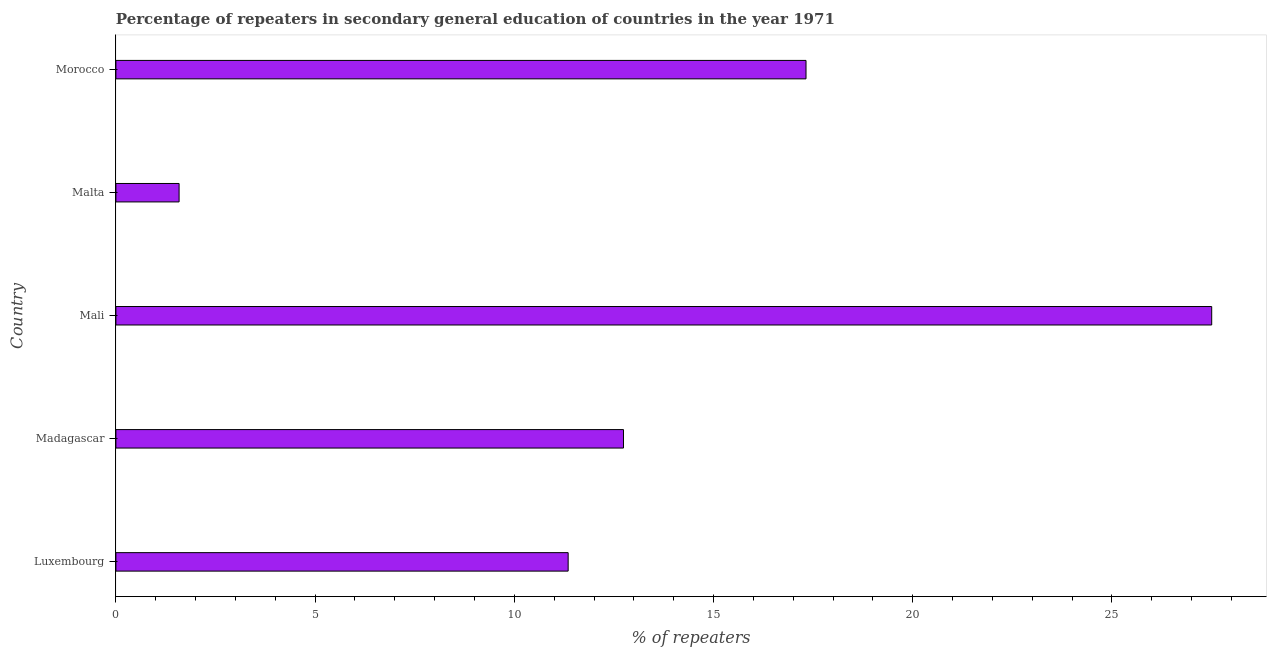Does the graph contain grids?
Your answer should be compact. No. What is the title of the graph?
Provide a short and direct response. Percentage of repeaters in secondary general education of countries in the year 1971. What is the label or title of the X-axis?
Your response must be concise. % of repeaters. What is the label or title of the Y-axis?
Your response must be concise. Country. What is the percentage of repeaters in Malta?
Provide a succinct answer. 1.59. Across all countries, what is the maximum percentage of repeaters?
Keep it short and to the point. 27.5. Across all countries, what is the minimum percentage of repeaters?
Give a very brief answer. 1.59. In which country was the percentage of repeaters maximum?
Provide a short and direct response. Mali. In which country was the percentage of repeaters minimum?
Your answer should be very brief. Malta. What is the sum of the percentage of repeaters?
Your answer should be compact. 70.5. What is the difference between the percentage of repeaters in Luxembourg and Madagascar?
Provide a succinct answer. -1.39. What is the average percentage of repeaters per country?
Offer a terse response. 14.1. What is the median percentage of repeaters?
Give a very brief answer. 12.74. What is the ratio of the percentage of repeaters in Luxembourg to that in Morocco?
Give a very brief answer. 0.66. What is the difference between the highest and the second highest percentage of repeaters?
Keep it short and to the point. 10.18. What is the difference between the highest and the lowest percentage of repeaters?
Make the answer very short. 25.92. How many bars are there?
Provide a short and direct response. 5. Are all the bars in the graph horizontal?
Your response must be concise. Yes. What is the difference between two consecutive major ticks on the X-axis?
Ensure brevity in your answer.  5. Are the values on the major ticks of X-axis written in scientific E-notation?
Your answer should be very brief. No. What is the % of repeaters of Luxembourg?
Ensure brevity in your answer.  11.35. What is the % of repeaters of Madagascar?
Keep it short and to the point. 12.74. What is the % of repeaters in Mali?
Give a very brief answer. 27.5. What is the % of repeaters of Malta?
Provide a succinct answer. 1.59. What is the % of repeaters of Morocco?
Provide a succinct answer. 17.32. What is the difference between the % of repeaters in Luxembourg and Madagascar?
Your answer should be compact. -1.39. What is the difference between the % of repeaters in Luxembourg and Mali?
Keep it short and to the point. -16.15. What is the difference between the % of repeaters in Luxembourg and Malta?
Give a very brief answer. 9.77. What is the difference between the % of repeaters in Luxembourg and Morocco?
Offer a terse response. -5.97. What is the difference between the % of repeaters in Madagascar and Mali?
Keep it short and to the point. -14.76. What is the difference between the % of repeaters in Madagascar and Malta?
Offer a terse response. 11.15. What is the difference between the % of repeaters in Madagascar and Morocco?
Offer a very short reply. -4.58. What is the difference between the % of repeaters in Mali and Malta?
Make the answer very short. 25.92. What is the difference between the % of repeaters in Mali and Morocco?
Your response must be concise. 10.18. What is the difference between the % of repeaters in Malta and Morocco?
Make the answer very short. -15.74. What is the ratio of the % of repeaters in Luxembourg to that in Madagascar?
Ensure brevity in your answer.  0.89. What is the ratio of the % of repeaters in Luxembourg to that in Mali?
Provide a short and direct response. 0.41. What is the ratio of the % of repeaters in Luxembourg to that in Malta?
Ensure brevity in your answer.  7.16. What is the ratio of the % of repeaters in Luxembourg to that in Morocco?
Your answer should be very brief. 0.66. What is the ratio of the % of repeaters in Madagascar to that in Mali?
Give a very brief answer. 0.46. What is the ratio of the % of repeaters in Madagascar to that in Malta?
Give a very brief answer. 8.03. What is the ratio of the % of repeaters in Madagascar to that in Morocco?
Offer a terse response. 0.74. What is the ratio of the % of repeaters in Mali to that in Malta?
Offer a terse response. 17.34. What is the ratio of the % of repeaters in Mali to that in Morocco?
Provide a short and direct response. 1.59. What is the ratio of the % of repeaters in Malta to that in Morocco?
Make the answer very short. 0.09. 